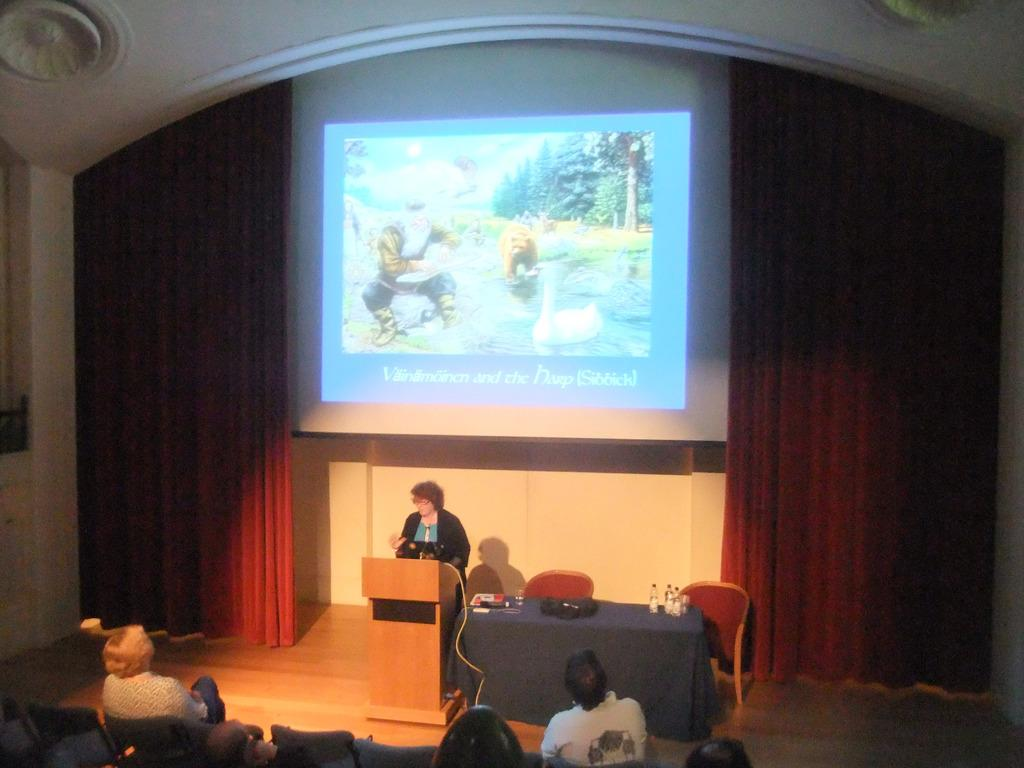How many people are visible in the image? There are people in the image, but the exact number cannot be determined from the provided facts. What type of furniture is present in the image? There is a table and chairs in the image. What is the purpose of the podium in the image? The purpose of the podium in the image cannot be determined from the provided facts. What type of objects can be seen in the image? There are objects in the image, but their specific nature cannot be determined from the provided facts. What can be seen in the background of the image? There is a wall, a curtain, and a screen in the background of the image. What type of mask is being worn by the person in the image? There is no mention of a mask or any person wearing a mask in the provided facts, so it cannot be determined from the image. What time of day is depicted in the image? The time of day cannot be determined from the provided facts, as there is no mention of lighting or shadows in the image. 